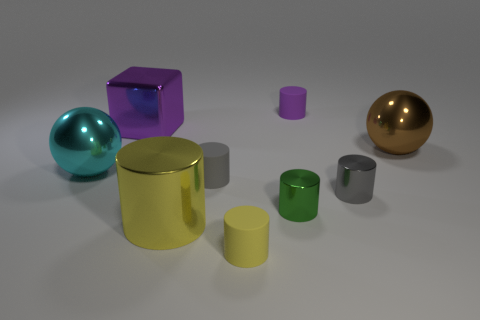What size is the green object that is made of the same material as the big cyan ball?
Make the answer very short. Small. Is there a object in front of the metal sphere that is on the right side of the small cylinder that is in front of the tiny green thing?
Your answer should be very brief. Yes. What number of metal cylinders are the same size as the gray metal thing?
Make the answer very short. 1. There is a cylinder behind the brown ball; is it the same size as the yellow matte thing that is on the right side of the big shiny cube?
Make the answer very short. Yes. There is a thing that is on the right side of the purple cylinder and behind the cyan thing; what is its shape?
Your response must be concise. Sphere. Is there a small matte cylinder that has the same color as the cube?
Provide a short and direct response. Yes. Are any blue matte balls visible?
Provide a succinct answer. No. The rubber cylinder that is behind the big cyan ball is what color?
Your response must be concise. Purple. Is the size of the brown metal ball the same as the object behind the cube?
Your answer should be very brief. No. What is the size of the object that is in front of the purple cube and behind the big cyan metal thing?
Ensure brevity in your answer.  Large. 